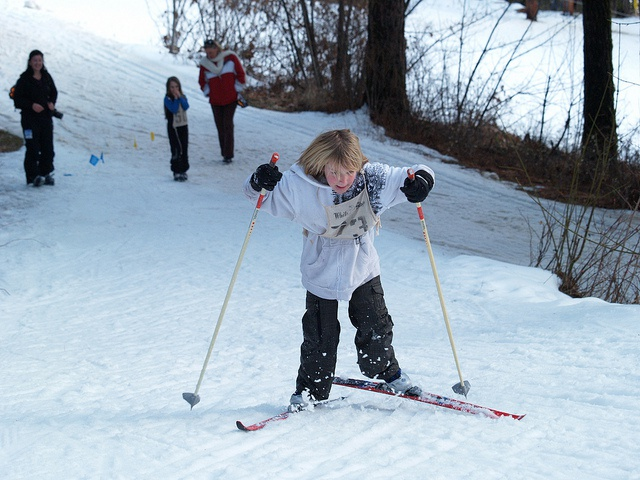Describe the objects in this image and their specific colors. I can see people in white, black, darkgray, and lightgray tones, people in white, black, gray, and navy tones, people in white, black, maroon, and gray tones, skis in white, lightgray, darkgray, and lightblue tones, and people in white, black, gray, navy, and blue tones in this image. 